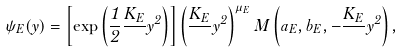Convert formula to latex. <formula><loc_0><loc_0><loc_500><loc_500>\psi _ { E } ( y ) = \left [ \exp \left ( \frac { 1 } { 2 } \frac { K _ { E } } { } y ^ { 2 } \right ) \right ] \left ( \frac { K _ { E } } { } y ^ { 2 } \right ) ^ { \mu _ { E } } M \left ( a _ { E } , b _ { E } , - \frac { K _ { E } } { } y ^ { 2 } \right ) ,</formula> 